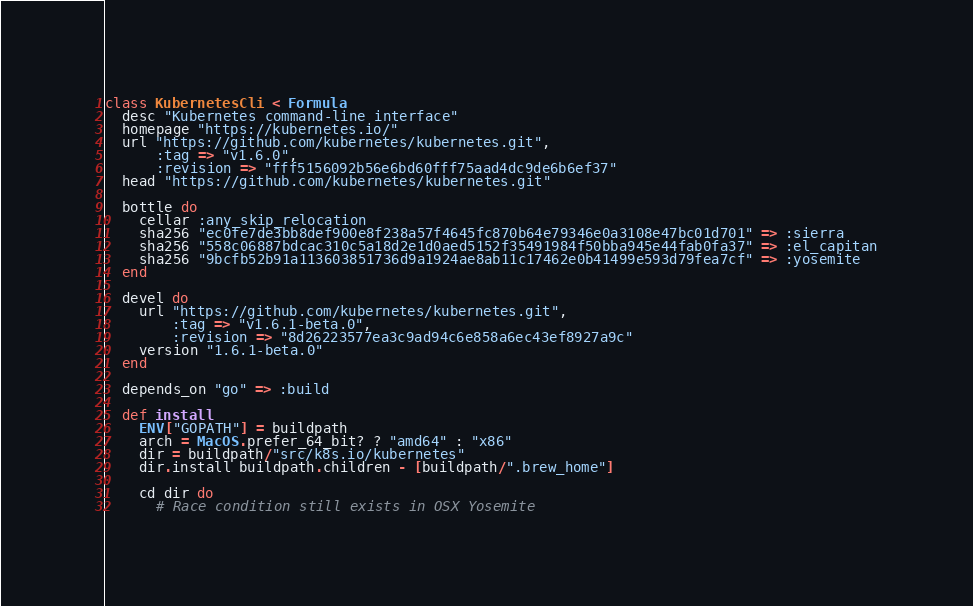Convert code to text. <code><loc_0><loc_0><loc_500><loc_500><_Ruby_>class KubernetesCli < Formula
  desc "Kubernetes command-line interface"
  homepage "https://kubernetes.io/"
  url "https://github.com/kubernetes/kubernetes.git",
      :tag => "v1.6.0",
      :revision => "fff5156092b56e6bd60fff75aad4dc9de6b6ef37"
  head "https://github.com/kubernetes/kubernetes.git"

  bottle do
    cellar :any_skip_relocation
    sha256 "ec0fe7de3bb8def900e8f238a57f4645fc870b64e79346e0a3108e47bc01d701" => :sierra
    sha256 "558c06887bdcac310c5a18d2e1d0aed5152f35491984f50bba945e44fab0fa37" => :el_capitan
    sha256 "9bcfb52b91a113603851736d9a1924ae8ab11c17462e0b41499e593d79fea7cf" => :yosemite
  end

  devel do
    url "https://github.com/kubernetes/kubernetes.git",
        :tag => "v1.6.1-beta.0",
        :revision => "8d26223577ea3c9ad94c6e858a6ec43ef8927a9c"
    version "1.6.1-beta.0"
  end

  depends_on "go" => :build

  def install
    ENV["GOPATH"] = buildpath
    arch = MacOS.prefer_64_bit? ? "amd64" : "x86"
    dir = buildpath/"src/k8s.io/kubernetes"
    dir.install buildpath.children - [buildpath/".brew_home"]

    cd dir do
      # Race condition still exists in OSX Yosemite</code> 